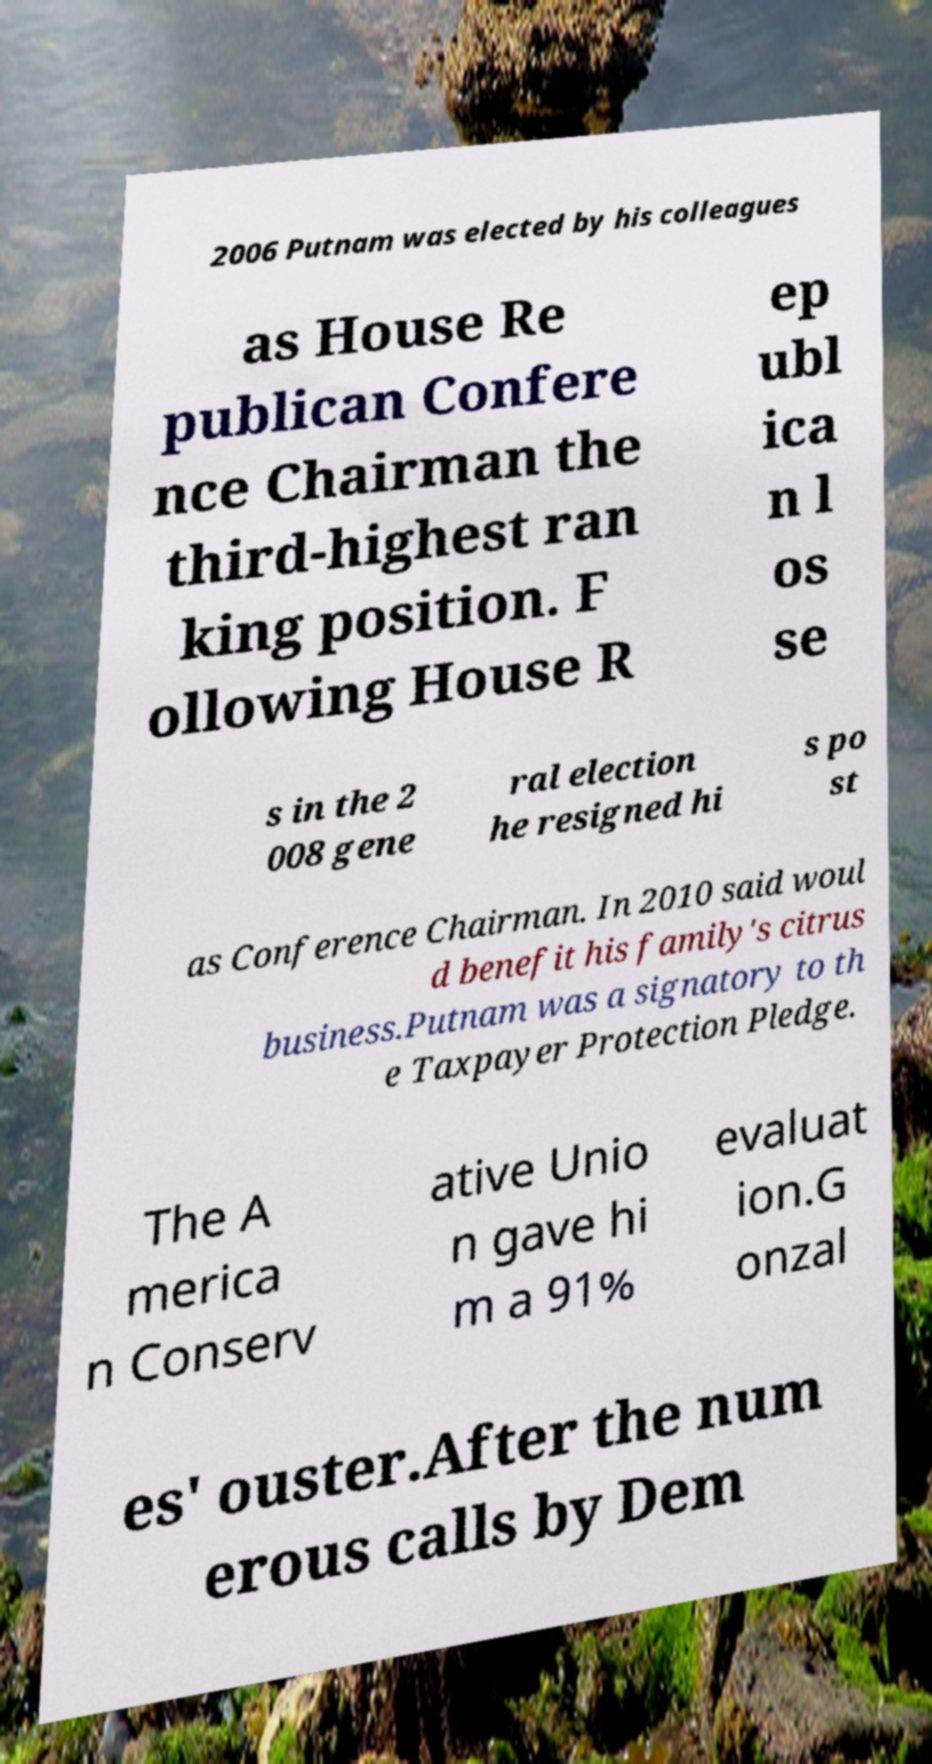Can you read and provide the text displayed in the image?This photo seems to have some interesting text. Can you extract and type it out for me? 2006 Putnam was elected by his colleagues as House Re publican Confere nce Chairman the third-highest ran king position. F ollowing House R ep ubl ica n l os se s in the 2 008 gene ral election he resigned hi s po st as Conference Chairman. In 2010 said woul d benefit his family's citrus business.Putnam was a signatory to th e Taxpayer Protection Pledge. The A merica n Conserv ative Unio n gave hi m a 91% evaluat ion.G onzal es' ouster.After the num erous calls by Dem 